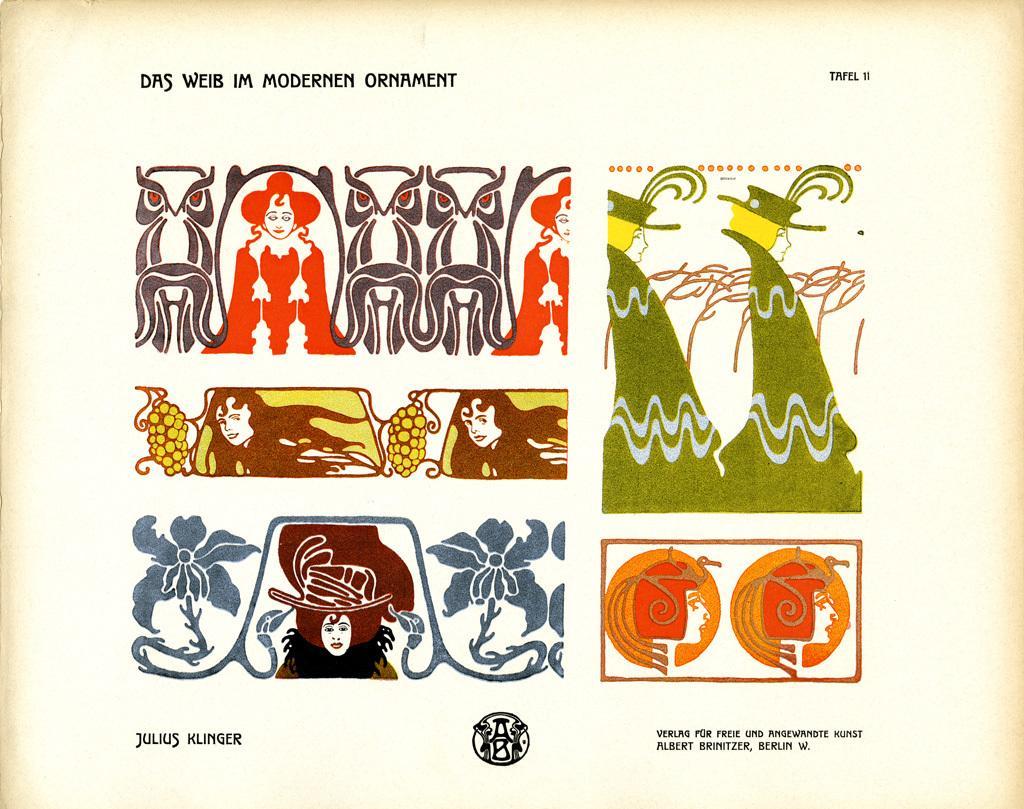In one or two sentences, can you explain what this image depicts? In this image we can see there is a poster. On the poster there are some images and text. 